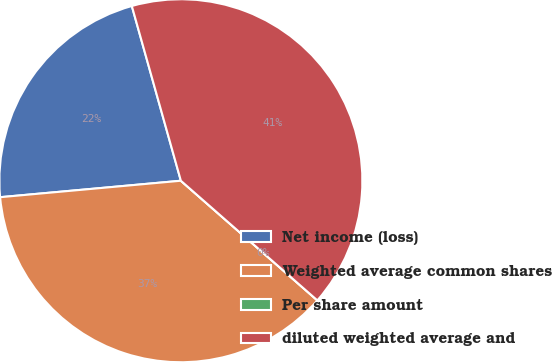Convert chart. <chart><loc_0><loc_0><loc_500><loc_500><pie_chart><fcel>Net income (loss)<fcel>Weighted average common shares<fcel>Per share amount<fcel>diluted weighted average and<nl><fcel>22.09%<fcel>37.1%<fcel>0.0%<fcel>40.81%<nl></chart> 